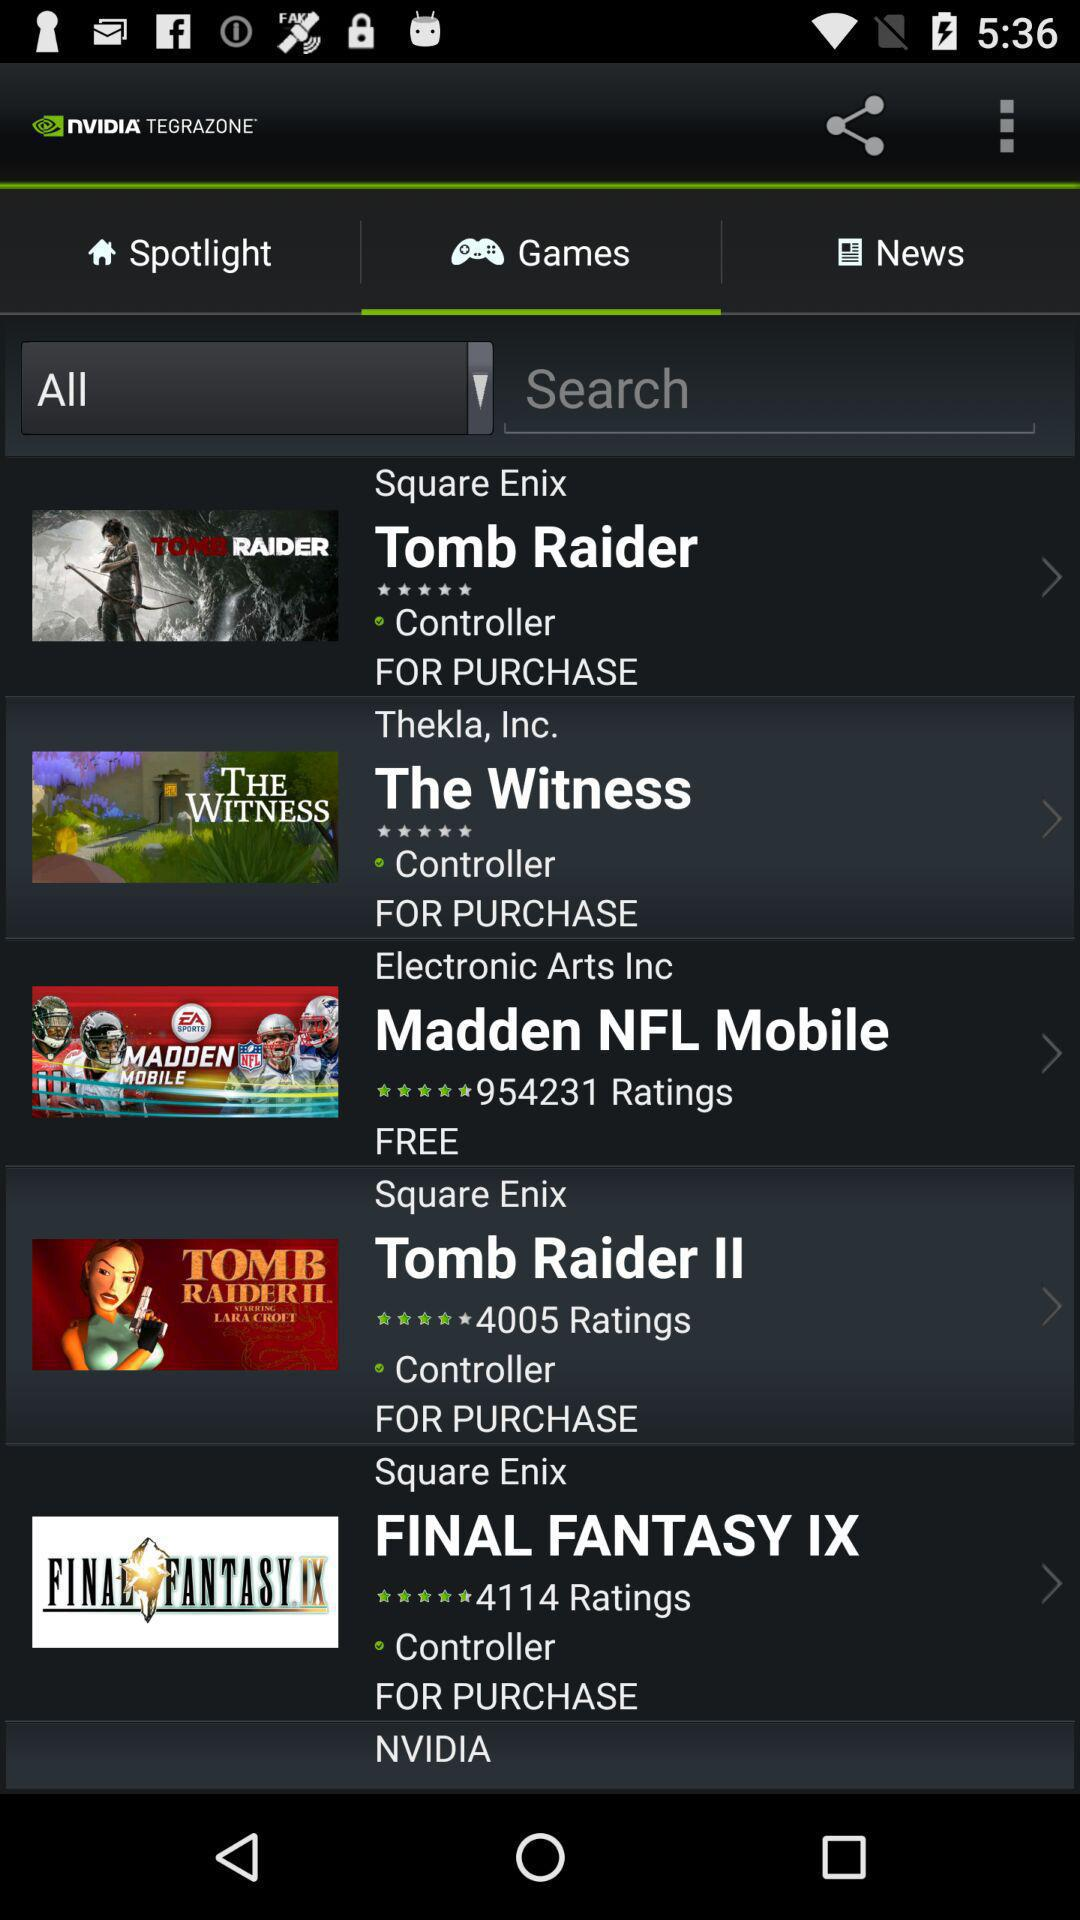How many people have given reviews on "Final Fantasy IX"? There are 4114 people who have given reviews on "Final Fantasy IX". 